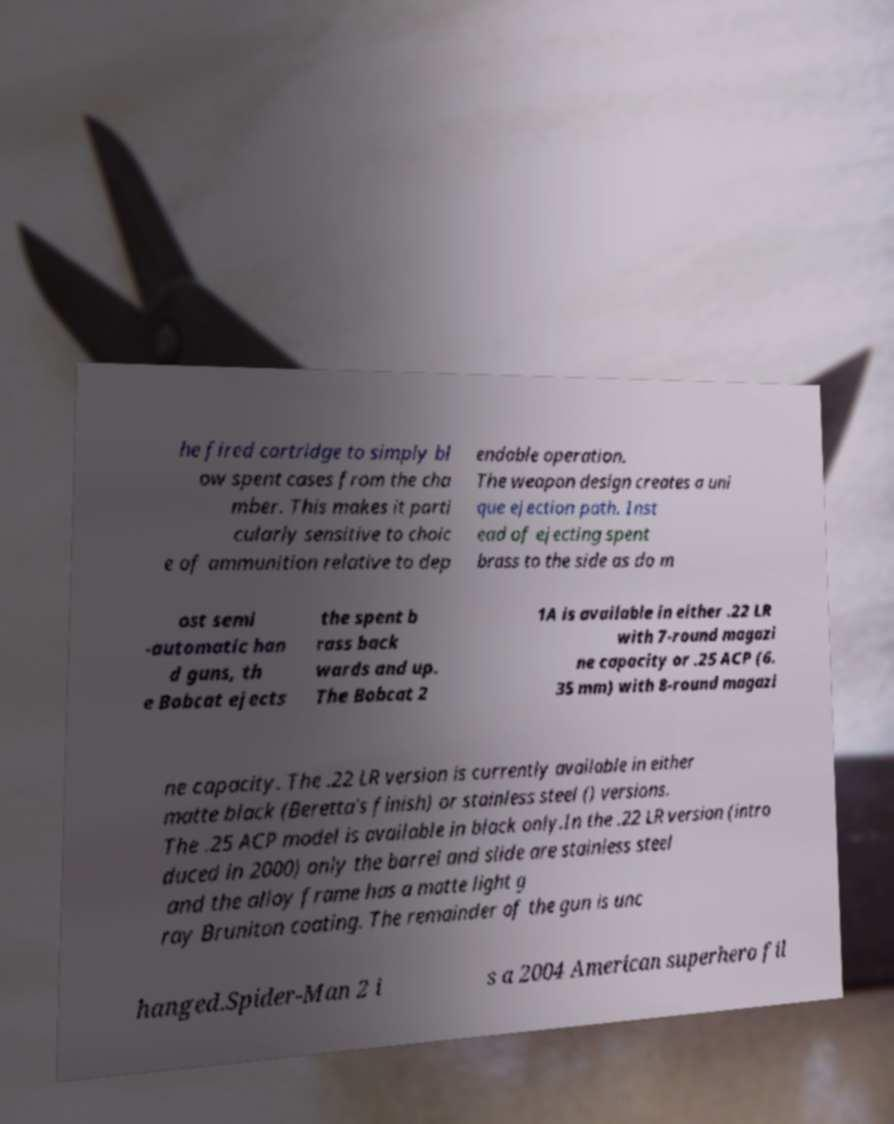Please identify and transcribe the text found in this image. he fired cartridge to simply bl ow spent cases from the cha mber. This makes it parti cularly sensitive to choic e of ammunition relative to dep endable operation. The weapon design creates a uni que ejection path. Inst ead of ejecting spent brass to the side as do m ost semi -automatic han d guns, th e Bobcat ejects the spent b rass back wards and up. The Bobcat 2 1A is available in either .22 LR with 7-round magazi ne capacity or .25 ACP (6. 35 mm) with 8-round magazi ne capacity. The .22 LR version is currently available in either matte black (Beretta's finish) or stainless steel () versions. The .25 ACP model is available in black only.In the .22 LR version (intro duced in 2000) only the barrel and slide are stainless steel and the alloy frame has a matte light g ray Bruniton coating. The remainder of the gun is unc hanged.Spider-Man 2 i s a 2004 American superhero fil 